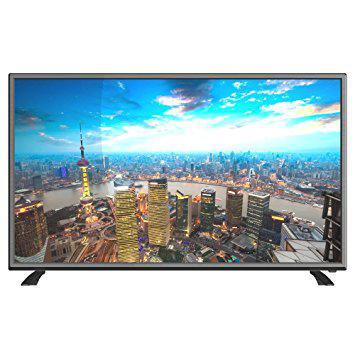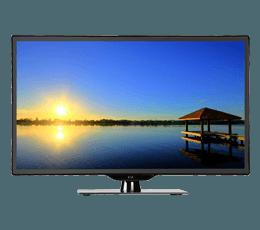The first image is the image on the left, the second image is the image on the right. Considering the images on both sides, is "The television on the left has leg stands." valid? Answer yes or no. Yes. The first image is the image on the left, the second image is the image on the right. Given the left and right images, does the statement "there is a sun glare in a monitor" hold true? Answer yes or no. Yes. 